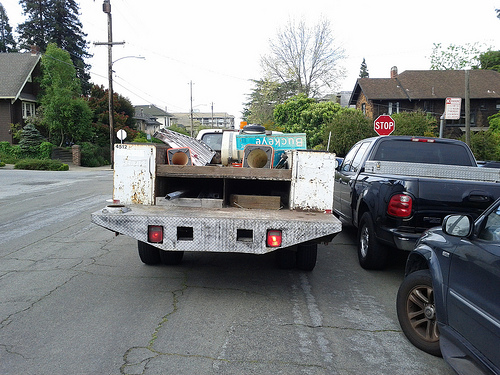Can you comment on the condition of the road and the surrounding environment? The road where the truck is parked appears to be in a residential area, with houses visible in the background. The road itself is showing signs of wear and minor cracks, but it seems overall to be in an adequate condition for driving. By the types of houses and vegetation, it suggests a suburban neighborhood. The stop sign indicates an intersection nearby, so the truck seems to be stationary in a spot where traffic manoeuvres are typical. 